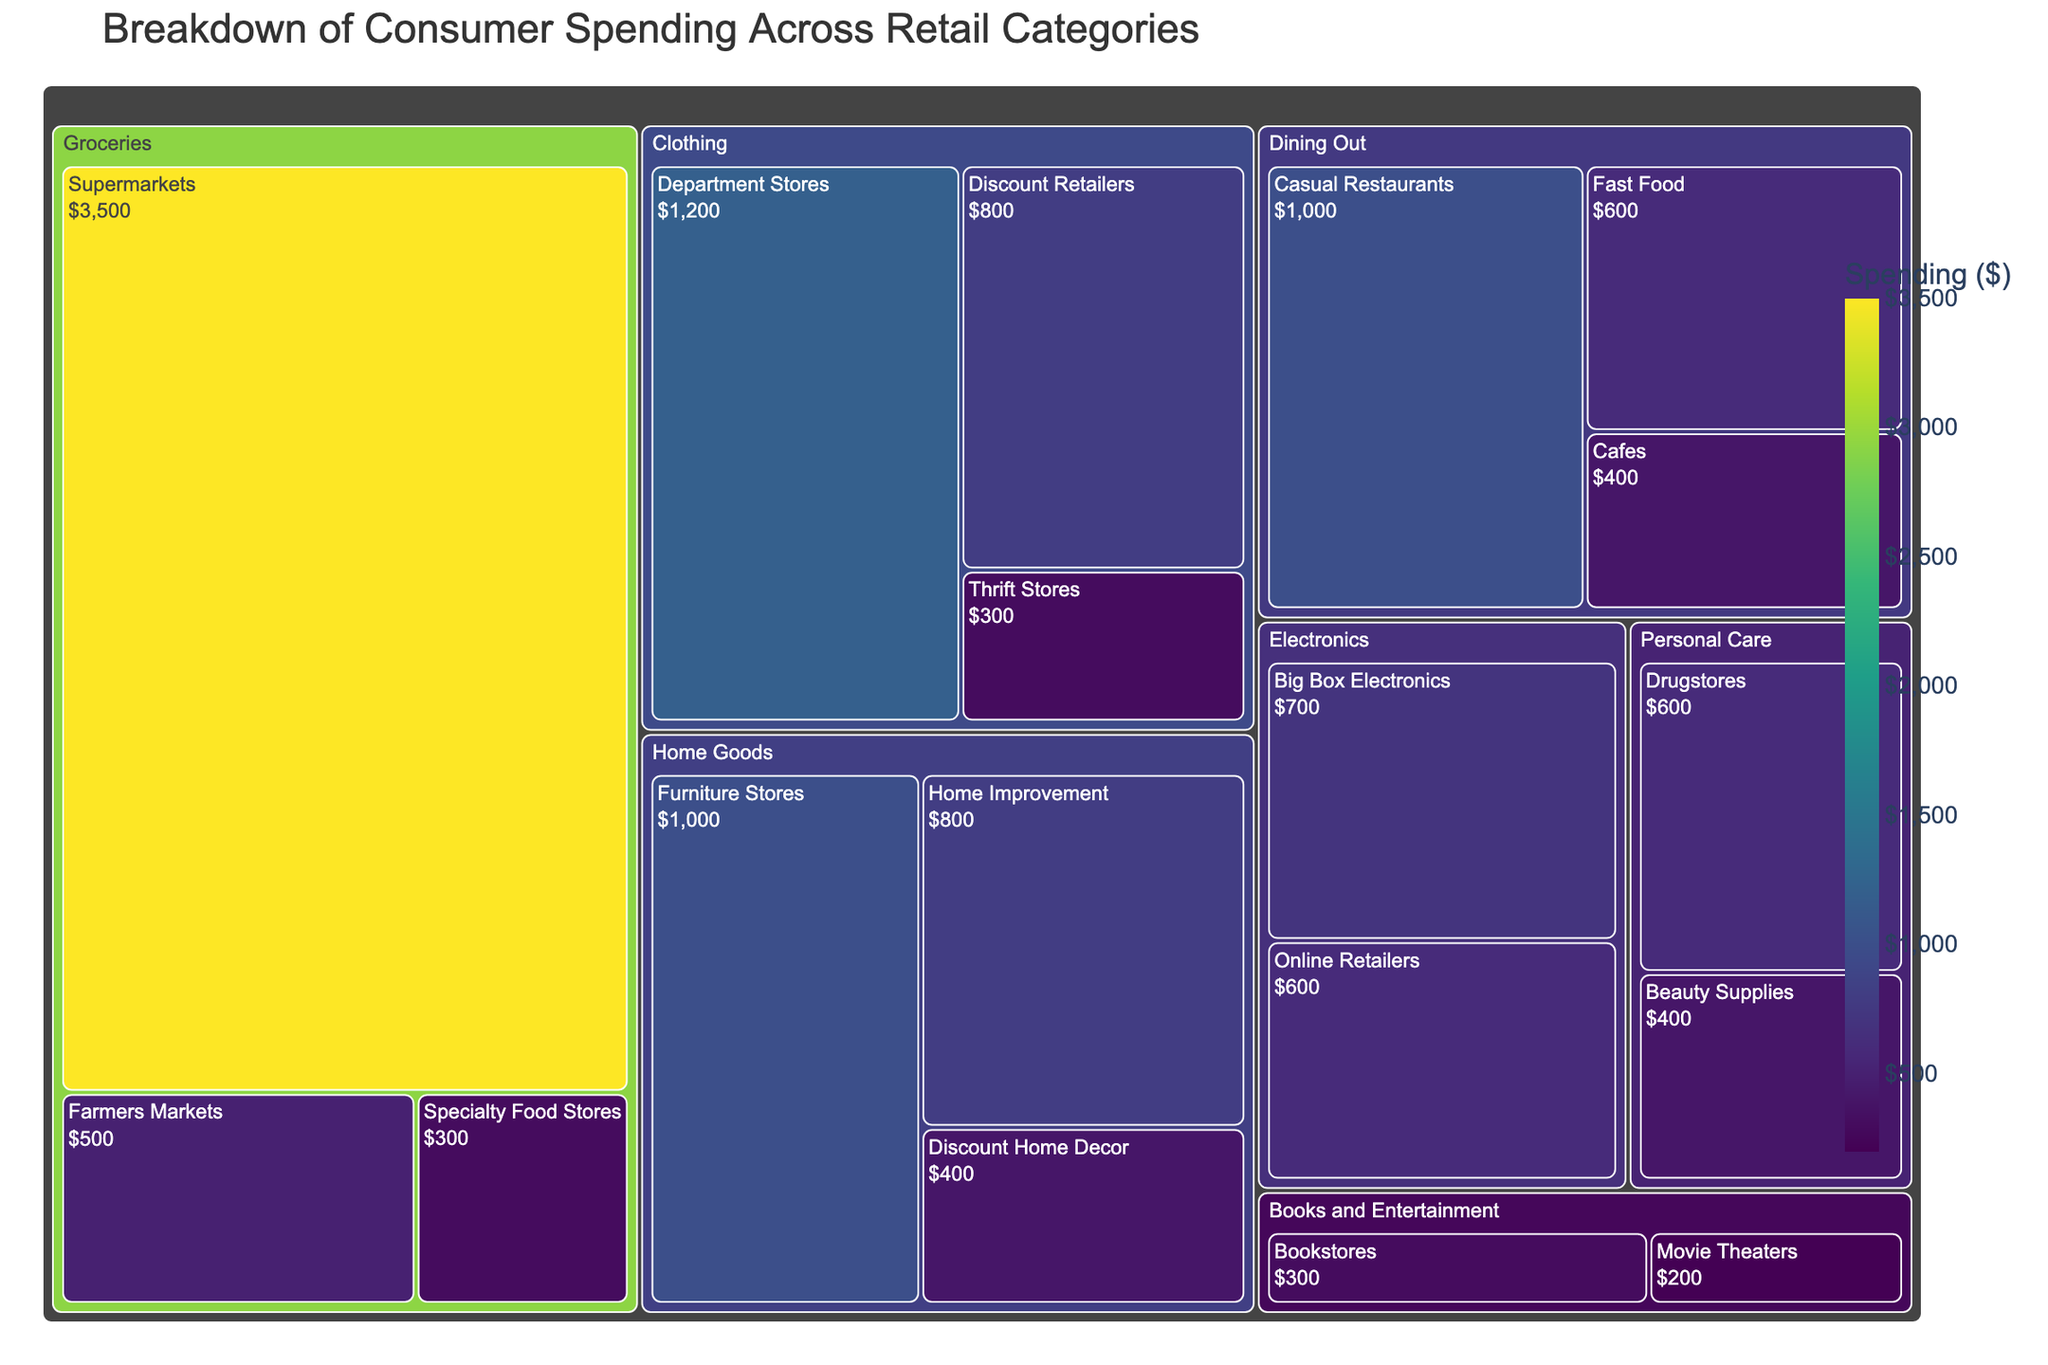What's the title of the figure? The title is usually displayed at the top of the figure. For this tree map, the title is "Breakdown of Consumer Spending Across Retail Categories".
Answer: Breakdown of Consumer Spending Across Retail Categories Which subcategory in "Dining Out" has the highest spending? By comparing the size and color of the rectangles under the "Dining Out" category, we can see that "Casual Restaurants" has the highest spending.
Answer: Casual Restaurants How much is spent on "Supermarkets" and "Farmers Markets" combined? Add the spending on "Supermarkets" and "Farmers Markets" within the "Groceries" category: $3500 (Supermarkets) + $500 (Farmers Markets) = $4000.
Answer: $4000 Which category has the least number of subcategories? Count the subcategories under each major category (Groceries: 3, Clothing: 3, Home Goods: 3, Electronics: 2, Personal Care: 2, Books and Entertainment: 2, Dining Out: 3). Several categories tie with 2 subcategories each, i.e., Electronics, Personal Care, and Books and Entertainment.
Answer: Electronics, Personal Care, Books and Entertainment What is the spending difference between "Big Box Electronics" and "Online Retailers"? Subtract the spending of "Online Retailers" from "Big Box Electronics": $700 (Big Box Electronics) - $600 (Online Retailers) = $100.
Answer: $100 Which subcategory in "Home Goods" has the lowest spending? Compare the spending in the subcategories under "Home Goods". "Discount Home Decor" has the lowest spending at $400.
Answer: Discount Home Decor What is the average spending on all the subcategories within the "Clothing" category? Calculate the total spending in "Clothing" by adding all subcategories: $1200 (Department Stores) + $800 (Discount Retailers) + $300 (Thrift Stores) = $2300. Then divide by the number of subcategories: $2300 / 3 = $766.67.
Answer: $766.67 Which major category has the highest combined spending? Sum the values of each major category and compare:
Groceries: $3500 + $500 + $300 = $4300
Clothing: $1200 + $800 + $300 = $2300
Home Goods: $1000 + $800 + $400 = $2200
Electronics: $700 + $600 = $1300
Personal Care: $600 + $400 = $1000
Books and Entertainment: $300 + $200 = $500
Dining Out: $1000 + $600 + $400 = $2000
Groceries have the highest combined spending.
Answer: Groceries Are there more subcategories in "Groceries" or in "Dining Out"? Count the number of subcategories in each category: Groceries have 3 subcategories ("Supermarkets", "Farmers Markets", "Specialty Food Stores") and Dining Out also has 3 subcategories ("Casual Restaurants", "Fast Food", "Cafes"). They are equal.
Answer: Equal 